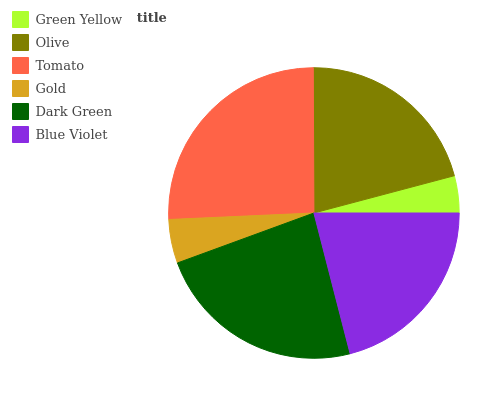Is Green Yellow the minimum?
Answer yes or no. Yes. Is Tomato the maximum?
Answer yes or no. Yes. Is Olive the minimum?
Answer yes or no. No. Is Olive the maximum?
Answer yes or no. No. Is Olive greater than Green Yellow?
Answer yes or no. Yes. Is Green Yellow less than Olive?
Answer yes or no. Yes. Is Green Yellow greater than Olive?
Answer yes or no. No. Is Olive less than Green Yellow?
Answer yes or no. No. Is Blue Violet the high median?
Answer yes or no. Yes. Is Olive the low median?
Answer yes or no. Yes. Is Dark Green the high median?
Answer yes or no. No. Is Gold the low median?
Answer yes or no. No. 